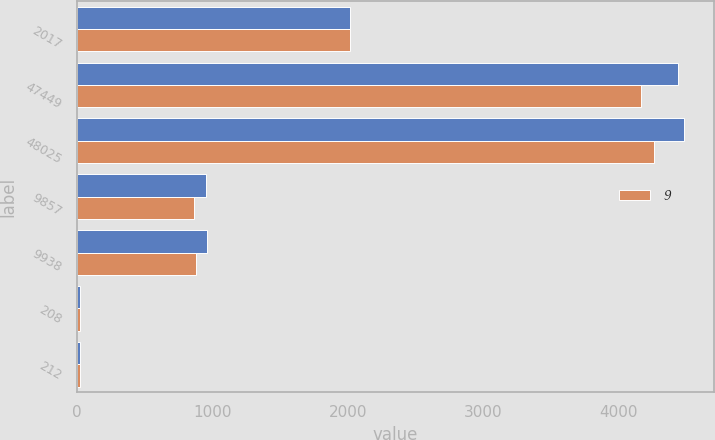Convert chart. <chart><loc_0><loc_0><loc_500><loc_500><stacked_bar_chart><ecel><fcel>2017<fcel>47449<fcel>48025<fcel>9857<fcel>9938<fcel>208<fcel>212<nl><fcel>nan<fcel>2016<fcel>4440.1<fcel>4483.5<fcel>950.5<fcel>956.7<fcel>21.4<fcel>21.6<nl><fcel>9<fcel>2015<fcel>4164.6<fcel>4260.6<fcel>867.1<fcel>878.6<fcel>20.8<fcel>21<nl></chart> 